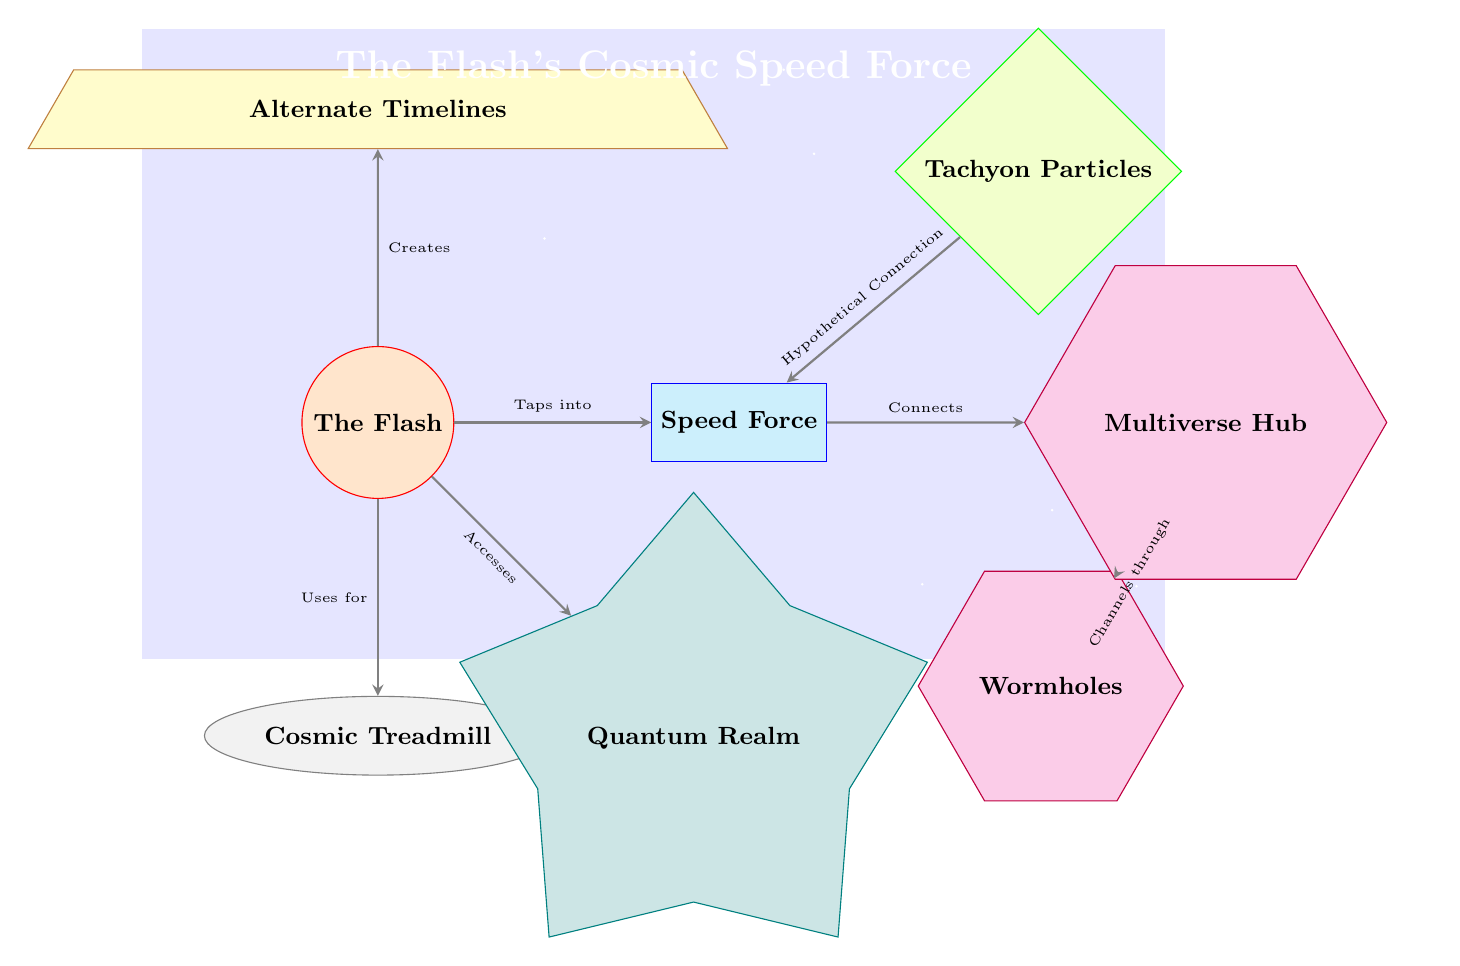What is the main hero depicted in the diagram? The diagram prominently features The Flash as indicated by the labeled node.
Answer: The Flash How many cosmic features are illustrated in the diagram? There are two cosmic features labeled: Wormholes and Multiverse Hub.
Answer: 2 What does The Flash tap into for his speed? According to the diagram, The Flash taps into the Speed Force as indicated by the directed edge.
Answer: Speed Force Which device does The Flash use? The diagram shows that The Flash uses the Cosmic Treadmill for his abilities, specified by the connection.
Answer: Cosmic Treadmill What do tachyon particles have with the Speed Force? Tachyon particles have a hypothetical connection to the Speed Force, as noted by the sloped edge pointing to the Speed Force node.
Answer: Hypothetical Connection How does the Speed Force relate to the multiverse? The relationship described in the diagram shows that the Speed Force connects to the Multiverse Hub, linking these two concepts directly.
Answer: Connects Which dimension is accessed by The Flash? The diagram indicates that The Flash accesses the Quantum Realm, illustrated by the sloped connection to the corresponding node.
Answer: Quantum Realm What do wormholes do in this context? According to the diagram, wormholes channel through to the Multiverse Hub, showing their functional path as demonstrated in the flowchart.
Answer: Channels through What is the direction of the edge from the Speed Force to the Multiverse Hub? The direction of the edge from the Speed Force to the Multiverse Hub is straightforward as it is indicated by an arrow that signifies the connection.
Answer: Connects 